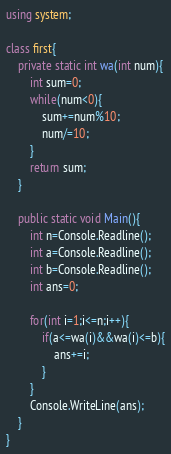<code> <loc_0><loc_0><loc_500><loc_500><_C#_>using system;

class first{
    private static int wa(int num){
        int sum=0;
        while(num<0){
            sum+=num%10;
            num/=10;
        }
        return sum;
    }

    public static void Main(){
        int n=Console.Readline();
        int a=Console.Readline();
        int b=Console.Readline();
        int ans=0;

        for(int i=1;i<=n;i++){
            if(a<=wa(i)&&wa(i)<=b){
                ans+=i;
            }
        }
        Console.WriteLine(ans);
    }
}</code> 